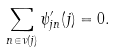<formula> <loc_0><loc_0><loc_500><loc_500>\sum _ { n \in \nu ( j ) } \psi ^ { \prime } _ { j n } ( j ) = 0 .</formula> 